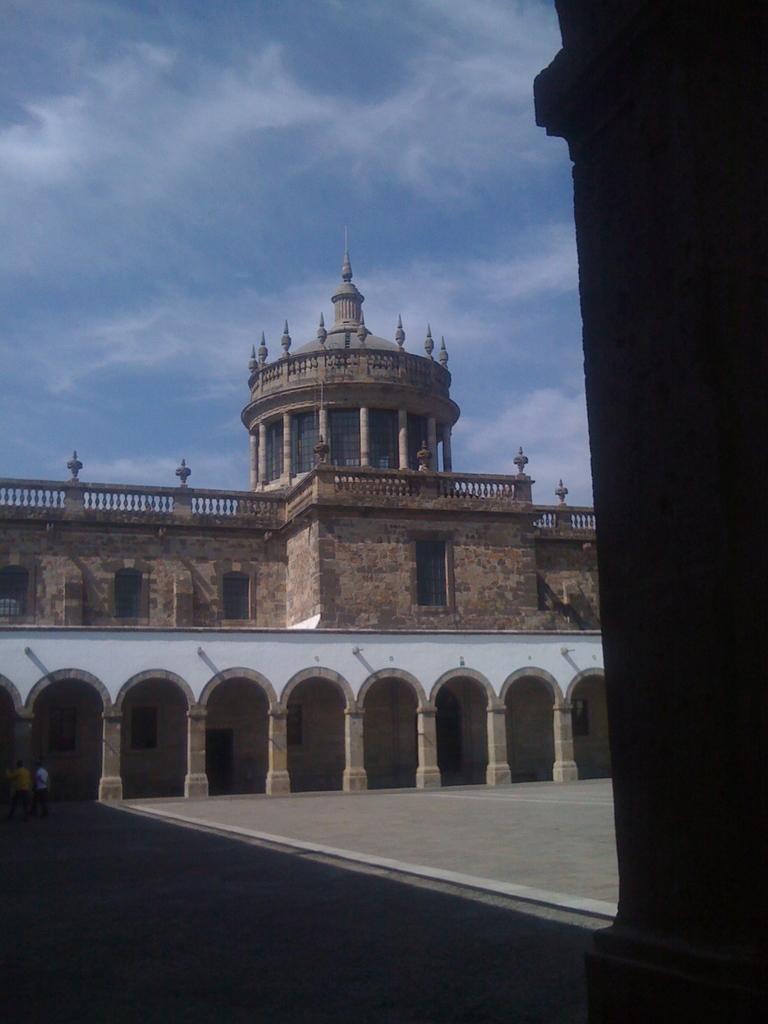Describe this image in one or two sentences. In this image there is a fort with rock pillars, in the fort there are a few people, at the top of the image there are clouds in the sky. 